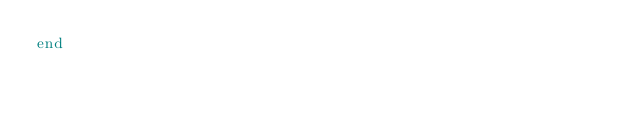Convert code to text. <code><loc_0><loc_0><loc_500><loc_500><_Ruby_>end
</code> 